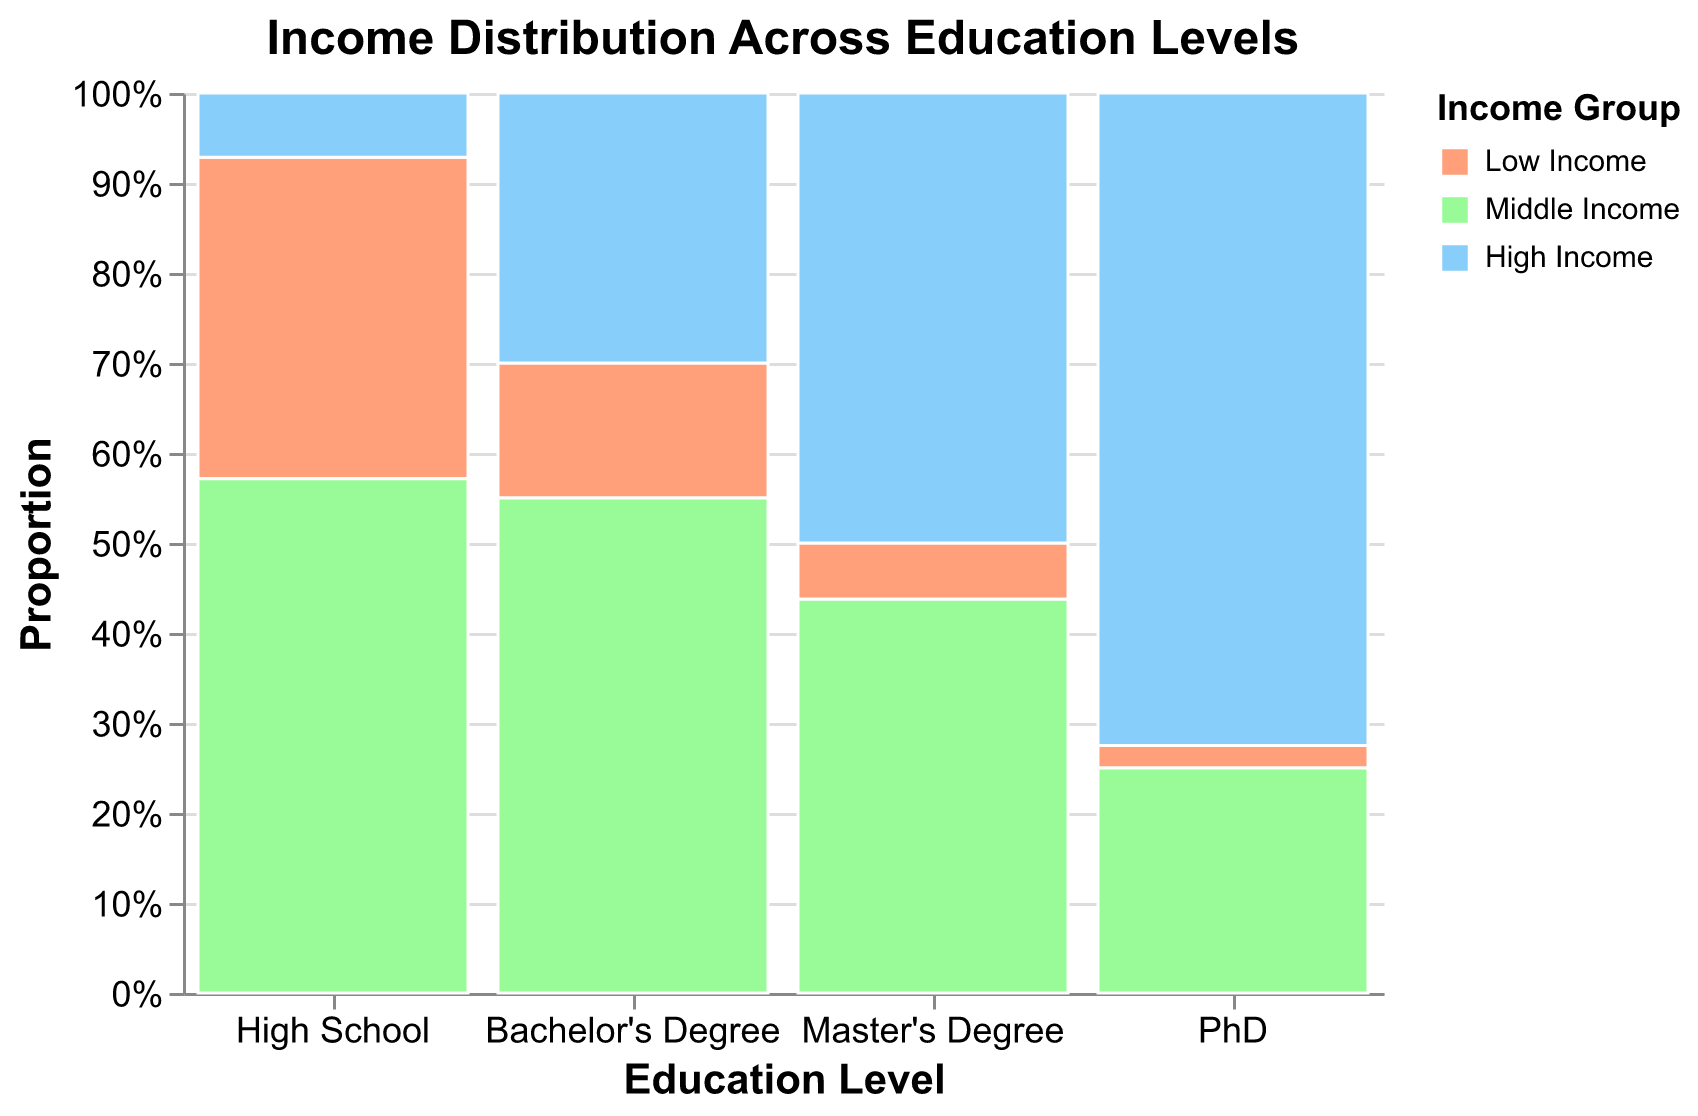What's the title of the figure? The title is prominently displayed at the top of the figure, which reads "Income Distribution Across Education Levels."
Answer: Income Distribution Across Education Levels What are the education levels shown on the X-axis? The X-axis displays four education levels: "High School," "Bachelor's Degree," "Master's Degree," and "PhD."
Answer: High School, Bachelor's Degree, Master's Degree, PhD Which color represents the Low Income group? In the legend on the right side of the figure, the Low Income group is represented by the color salmon (light orange).
Answer: Salmon (light orange) How many individuals with a Master's Degree are in the High Income group? The mosaic plot indicates that there are 4,000 individuals with a Master's Degree in the High Income group.
Answer: 4,000 What proportion of PhDs are in the High Income group? The mosaic plot's Y-axis represents proportions. For PhDs, the High Income section occupies the topmost segment, showing the relative proportion. This proportion is approximately 70%.
Answer: Approximately 70% How does the proportion of Middle Income compare between those with a Bachelor's Degree and those with a Master's Degree? On the Y-axis, the Middle Income group's proportion for Bachelor's Degrees appears larger than that for Master's Degrees. By visual inspection, the Bachelor's Degree segment is more than 40%, while the Master's Degree is 35%.
Answer: Bachelor's Degree Middle Income has a larger proportion, about 55% vs. Master's Degree's 35% Among individuals with a High School education, which income group has the highest number? The mosaic plot shows that for individuals with a High School education, the Middle Income group has the largest proportion.
Answer: Middle Income What is the total number of individuals in the Low Income groups across all education levels? Summing up the counts of the Low Income groups: High School (2500), Bachelor's Degree (1500), Master's Degree (500), PhD (100) gives us 2500 + 1500 + 500 + 100 = 4600.
Answer: 4600 What is the sum of people in the High Income group across all education levels? Summing up the counts of the High Income groups for all education levels: High School (500), Bachelor's Degree (3000), Master's Degree (4000), PhD (2900) gives us 500 + 3000 + 4000 + 2900 = 10400.
Answer: 10400 What is the most prevalent income group for individuals with Bachelor's Degrees, and what is its count? The largest segment for Bachelor's Degrees on the mosaic plot is the Middle Income group, which has 5500 individuals.
Answer: Middle Income, 5500 